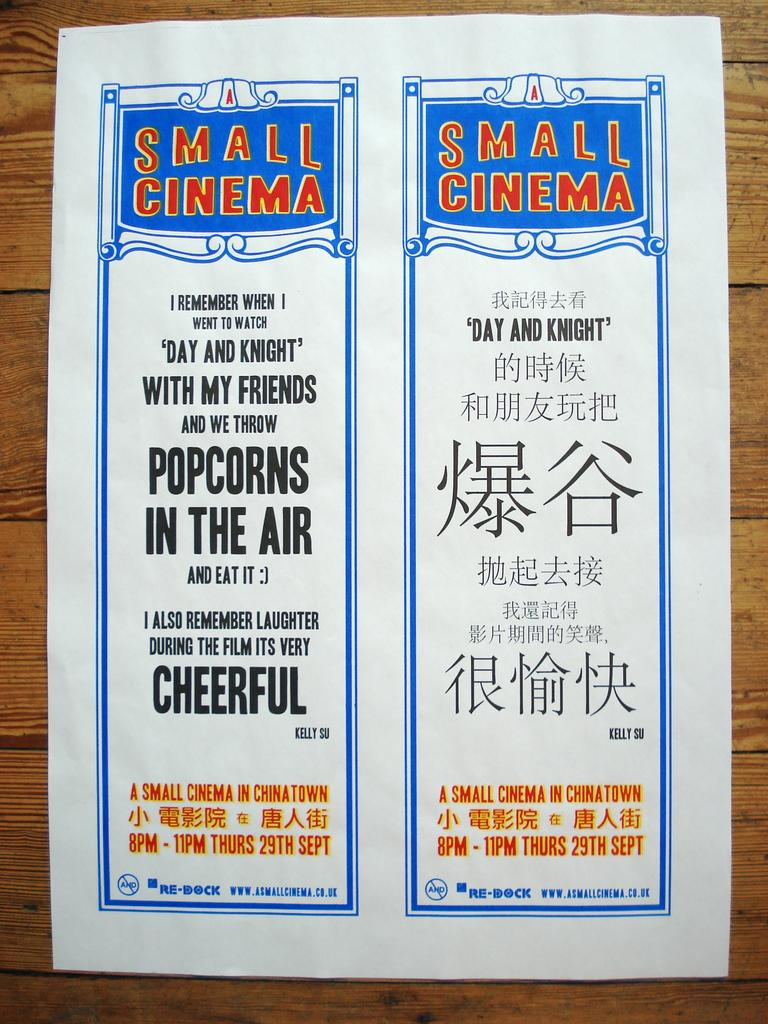<image>
Describe the image concisely. Poster showing two advertisments, one in English and the second one in an asian language for the Small Theater. 